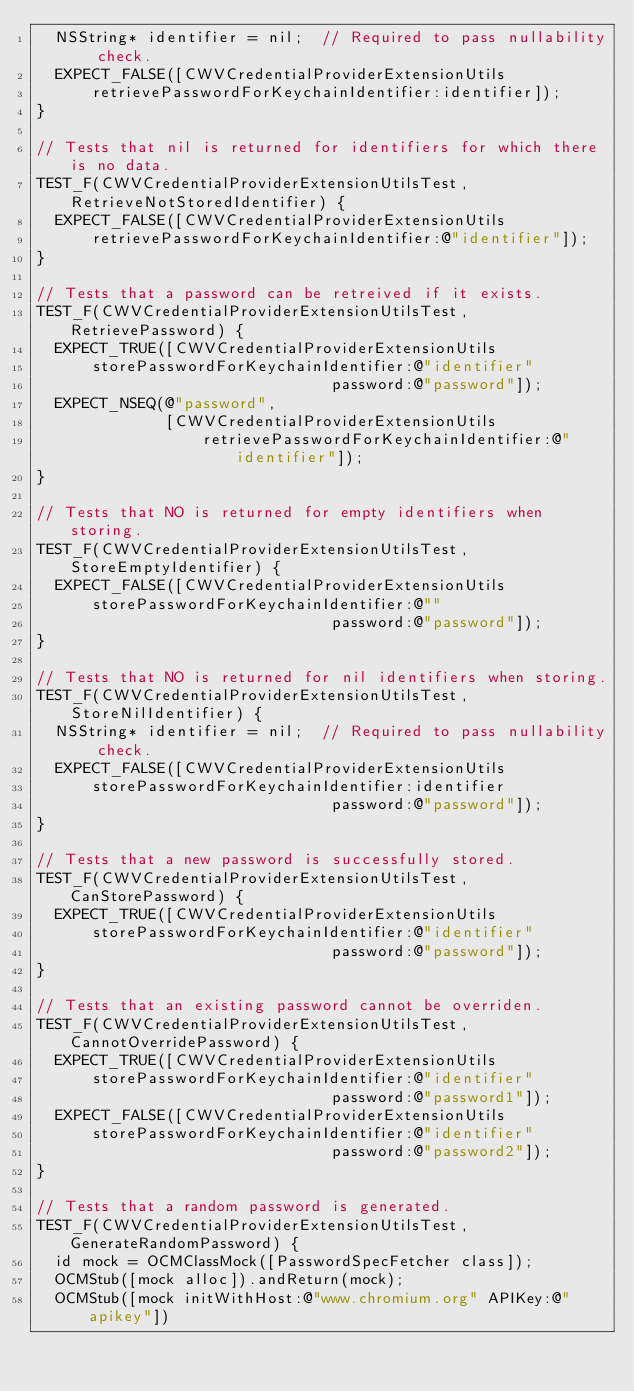Convert code to text. <code><loc_0><loc_0><loc_500><loc_500><_ObjectiveC_>  NSString* identifier = nil;  // Required to pass nullability check.
  EXPECT_FALSE([CWVCredentialProviderExtensionUtils
      retrievePasswordForKeychainIdentifier:identifier]);
}

// Tests that nil is returned for identifiers for which there is no data.
TEST_F(CWVCredentialProviderExtensionUtilsTest, RetrieveNotStoredIdentifier) {
  EXPECT_FALSE([CWVCredentialProviderExtensionUtils
      retrievePasswordForKeychainIdentifier:@"identifier"]);
}

// Tests that a password can be retreived if it exists.
TEST_F(CWVCredentialProviderExtensionUtilsTest, RetrievePassword) {
  EXPECT_TRUE([CWVCredentialProviderExtensionUtils
      storePasswordForKeychainIdentifier:@"identifier"
                                password:@"password"]);
  EXPECT_NSEQ(@"password",
              [CWVCredentialProviderExtensionUtils
                  retrievePasswordForKeychainIdentifier:@"identifier"]);
}

// Tests that NO is returned for empty identifiers when storing.
TEST_F(CWVCredentialProviderExtensionUtilsTest, StoreEmptyIdentifier) {
  EXPECT_FALSE([CWVCredentialProviderExtensionUtils
      storePasswordForKeychainIdentifier:@""
                                password:@"password"]);
}

// Tests that NO is returned for nil identifiers when storing.
TEST_F(CWVCredentialProviderExtensionUtilsTest, StoreNilIdentifier) {
  NSString* identifier = nil;  // Required to pass nullability check.
  EXPECT_FALSE([CWVCredentialProviderExtensionUtils
      storePasswordForKeychainIdentifier:identifier
                                password:@"password"]);
}

// Tests that a new password is successfully stored.
TEST_F(CWVCredentialProviderExtensionUtilsTest, CanStorePassword) {
  EXPECT_TRUE([CWVCredentialProviderExtensionUtils
      storePasswordForKeychainIdentifier:@"identifier"
                                password:@"password"]);
}

// Tests that an existing password cannot be overriden.
TEST_F(CWVCredentialProviderExtensionUtilsTest, CannotOverridePassword) {
  EXPECT_TRUE([CWVCredentialProviderExtensionUtils
      storePasswordForKeychainIdentifier:@"identifier"
                                password:@"password1"]);
  EXPECT_FALSE([CWVCredentialProviderExtensionUtils
      storePasswordForKeychainIdentifier:@"identifier"
                                password:@"password2"]);
}

// Tests that a random password is generated.
TEST_F(CWVCredentialProviderExtensionUtilsTest, GenerateRandomPassword) {
  id mock = OCMClassMock([PasswordSpecFetcher class]);
  OCMStub([mock alloc]).andReturn(mock);
  OCMStub([mock initWithHost:@"www.chromium.org" APIKey:@"apikey"])</code> 